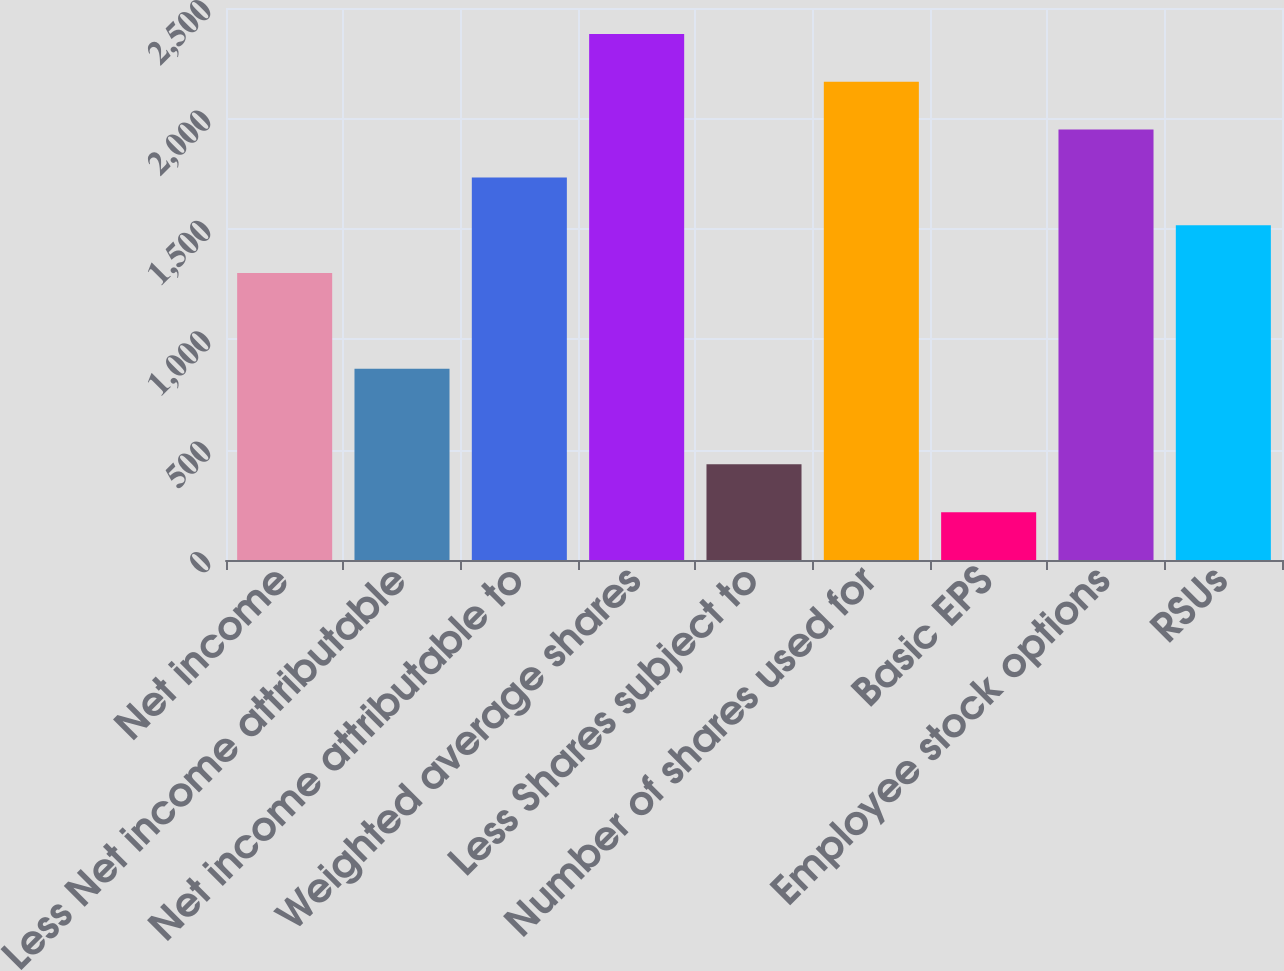<chart> <loc_0><loc_0><loc_500><loc_500><bar_chart><fcel>Net income<fcel>Less Net income attributable<fcel>Net income attributable to<fcel>Weighted average shares<fcel>Less Shares subject to<fcel>Number of shares used for<fcel>Basic EPS<fcel>Employee stock options<fcel>RSUs<nl><fcel>1299.61<fcel>866.41<fcel>1732.81<fcel>2382.61<fcel>433.21<fcel>2166.01<fcel>216.61<fcel>1949.41<fcel>1516.21<nl></chart> 